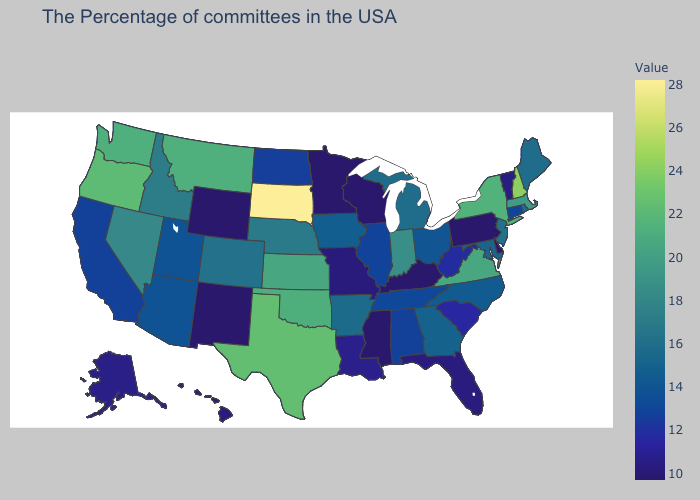Which states have the highest value in the USA?
Quick response, please. South Dakota. Does South Dakota have the highest value in the USA?
Keep it brief. Yes. Does Texas have a lower value than South Dakota?
Concise answer only. Yes. Among the states that border California , which have the highest value?
Keep it brief. Oregon. Does Utah have the lowest value in the West?
Give a very brief answer. No. 